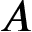Convert formula to latex. <formula><loc_0><loc_0><loc_500><loc_500>A</formula> 